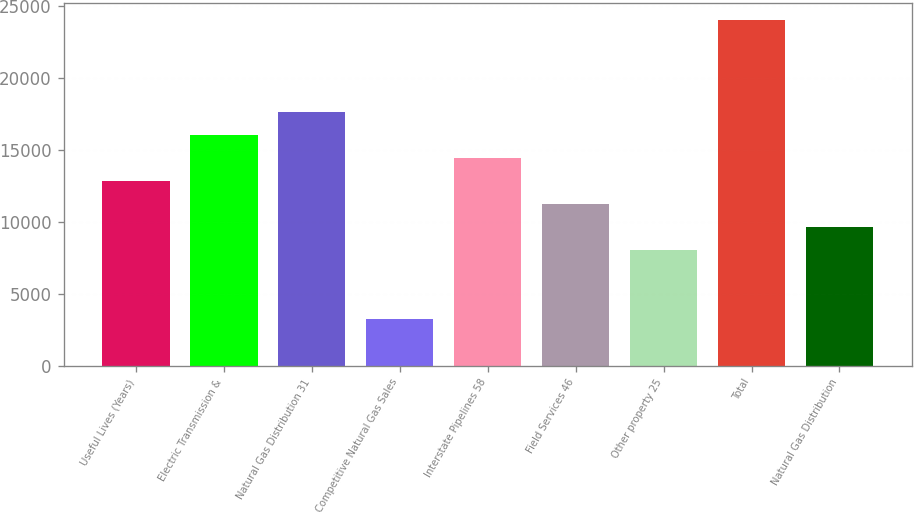Convert chart to OTSL. <chart><loc_0><loc_0><loc_500><loc_500><bar_chart><fcel>Useful Lives (Years)<fcel>Electric Transmission &<fcel>Natural Gas Distribution 31<fcel>Competitive Natural Gas Sales<fcel>Interstate Pipelines 58<fcel>Field Services 46<fcel>Other property 25<fcel>Total<fcel>Natural Gas Distribution<nl><fcel>12807.2<fcel>16005<fcel>17603.9<fcel>3213.8<fcel>14406.1<fcel>11208.3<fcel>8010.5<fcel>23999.5<fcel>9609.4<nl></chart> 